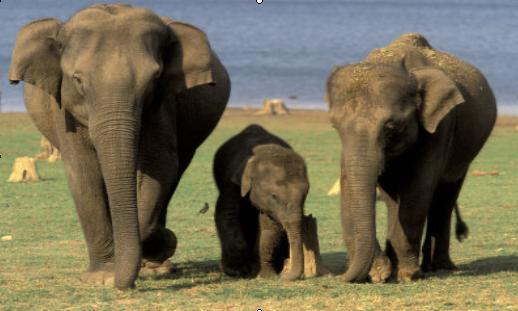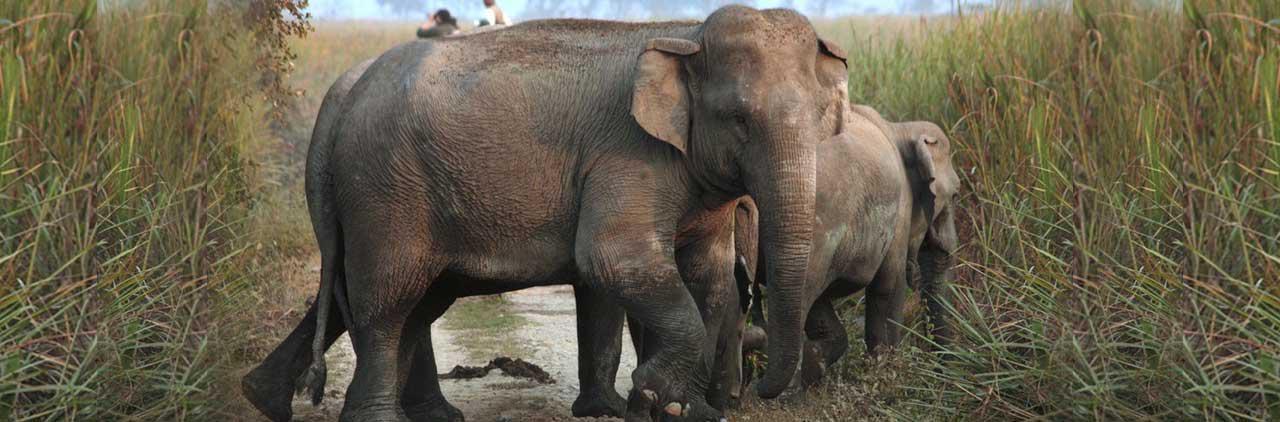The first image is the image on the left, the second image is the image on the right. Examine the images to the left and right. Is the description "At least one image is exactly one baby elephant standing between two adults." accurate? Answer yes or no. Yes. 